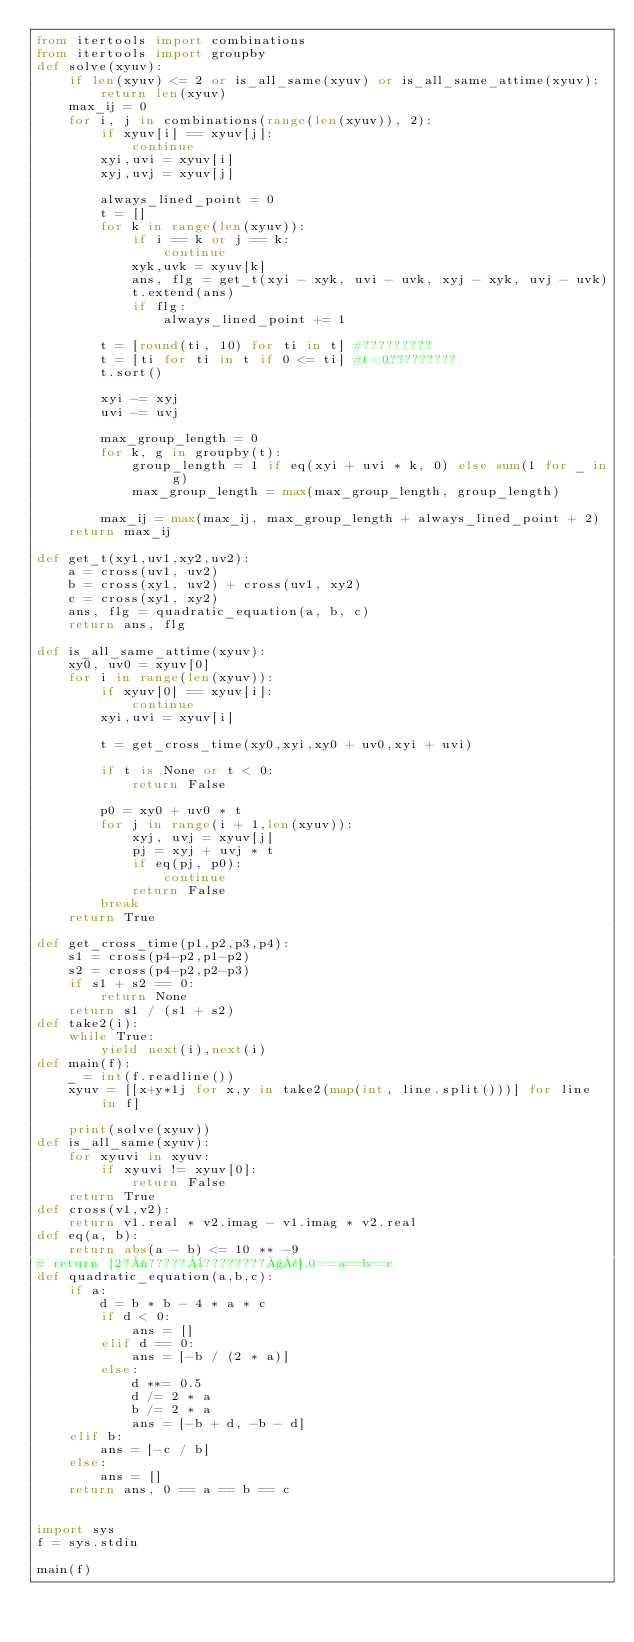Convert code to text. <code><loc_0><loc_0><loc_500><loc_500><_Python_>from itertools import combinations
from itertools import groupby
def solve(xyuv):
    if len(xyuv) <= 2 or is_all_same(xyuv) or is_all_same_attime(xyuv):
        return len(xyuv)
    max_ij = 0
    for i, j in combinations(range(len(xyuv)), 2):
        if xyuv[i] == xyuv[j]:
            continue
        xyi,uvi = xyuv[i]
        xyj,uvj = xyuv[j]
            
        always_lined_point = 0
        t = []
        for k in range(len(xyuv)):
            if i == k or j == k:
                continue
            xyk,uvk = xyuv[k]
            ans, flg = get_t(xyi - xyk, uvi - uvk, xyj - xyk, uvj - uvk)
            t.extend(ans)
            if flg:
                always_lined_point += 1

        t = [round(ti, 10) for ti in t] #?????????
        t = [ti for ti in t if 0 <= ti] #t<0?????????
        t.sort()
        
        xyi -= xyj
        uvi -= uvj

        max_group_length = 0
        for k, g in groupby(t):
            group_length = 1 if eq(xyi + uvi * k, 0) else sum(1 for _ in g)
            max_group_length = max(max_group_length, group_length)
            
        max_ij = max(max_ij, max_group_length + always_lined_point + 2)
    return max_ij

def get_t(xy1,uv1,xy2,uv2):
    a = cross(uv1, uv2)
    b = cross(xy1, uv2) + cross(uv1, xy2)
    c = cross(xy1, xy2)
    ans, flg = quadratic_equation(a, b, c)
    return ans, flg

def is_all_same_attime(xyuv):
    xy0, uv0 = xyuv[0]
    for i in range(len(xyuv)):
        if xyuv[0] == xyuv[i]:
            continue
        xyi,uvi = xyuv[i]

        t = get_cross_time(xy0,xyi,xy0 + uv0,xyi + uvi)

        if t is None or t < 0:
            return False

        p0 = xy0 + uv0 * t
        for j in range(i + 1,len(xyuv)):
            xyj, uvj = xyuv[j]
            pj = xyj + uvj * t
            if eq(pj, p0):
                continue
            return False
        break
    return True

def get_cross_time(p1,p2,p3,p4):
    s1 = cross(p4-p2,p1-p2)
    s2 = cross(p4-p2,p2-p3)
    if s1 + s2 == 0:
        return None
    return s1 / (s1 + s2)
def take2(i):
    while True:
        yield next(i),next(i)
def main(f):
    _ = int(f.readline())
    xyuv = [[x+y*1j for x,y in take2(map(int, line.split()))] for line in f]

    print(solve(xyuv))
def is_all_same(xyuv):
    for xyuvi in xyuv:
        if xyuvi != xyuv[0]:
            return False
    return True
def cross(v1,v2):
    return v1.real * v2.imag - v1.imag * v2.real
def eq(a, b):
    return abs(a - b) <= 10 ** -9
# return [2?¬?????¨????????§£],0==a==b==c
def quadratic_equation(a,b,c):
    if a:
        d = b * b - 4 * a * c
        if d < 0:
            ans = []
        elif d == 0:
            ans = [-b / (2 * a)]
        else:
            d **= 0.5
            d /= 2 * a
            b /= 2 * a
            ans = [-b + d, -b - d]
    elif b:
        ans = [-c / b]
    else:
        ans = []
    return ans, 0 == a == b == c


import sys
f = sys.stdin

main(f)</code> 